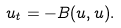Convert formula to latex. <formula><loc_0><loc_0><loc_500><loc_500>u _ { t } = - B ( u , u ) .</formula> 